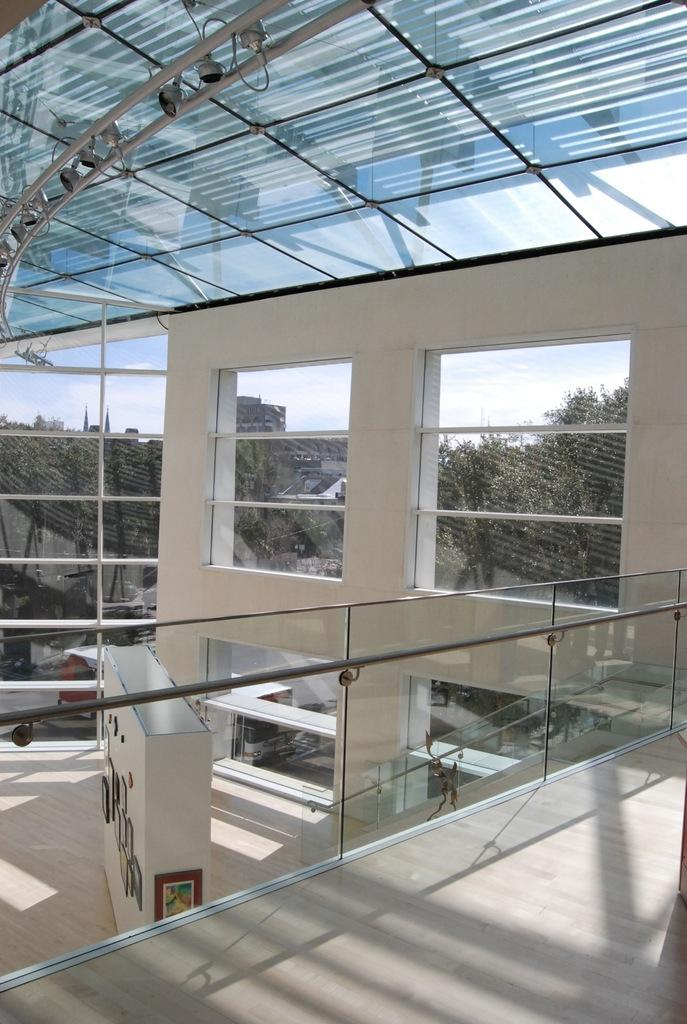What does the image show in terms of a building's structure? The image shows the internal structure of a building. Are there any openings in the building for natural light? Yes, there are windows in the building. What can be seen through the windows in the image? Trees and the sky are visible through the windows. How would you describe the weather based on the sky in the image? The sky appears to be cloudy in the image. Can you identify any architectural elements in the image? Yes, there is a frame and a roof visible in the image. Is there any source of light in the image? Yes, light is present in the image. What type of skin condition can be seen on the trees through the windows in the image? There is no mention of any skin condition on the trees in the image. The trees and sky are visible through the windows, but their condition is not discussed. 